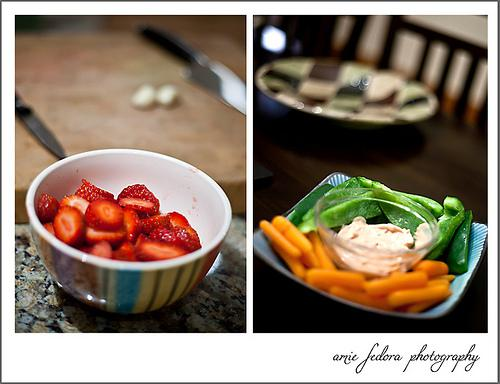Question: how are the strawberries cut?
Choices:
A. Fourths.
B. Circular.
C. Slices.
D. Squares.
Answer with the letter. Answer: C Question: who sliced the food?
Choices:
A. Cook.
B. A man.
C. A woman.
D. A child.
Answer with the letter. Answer: A Question: what is the food in?
Choices:
A. Container.
B. Bowls.
C. Tupperware.
D. A pan.
Answer with the letter. Answer: B 